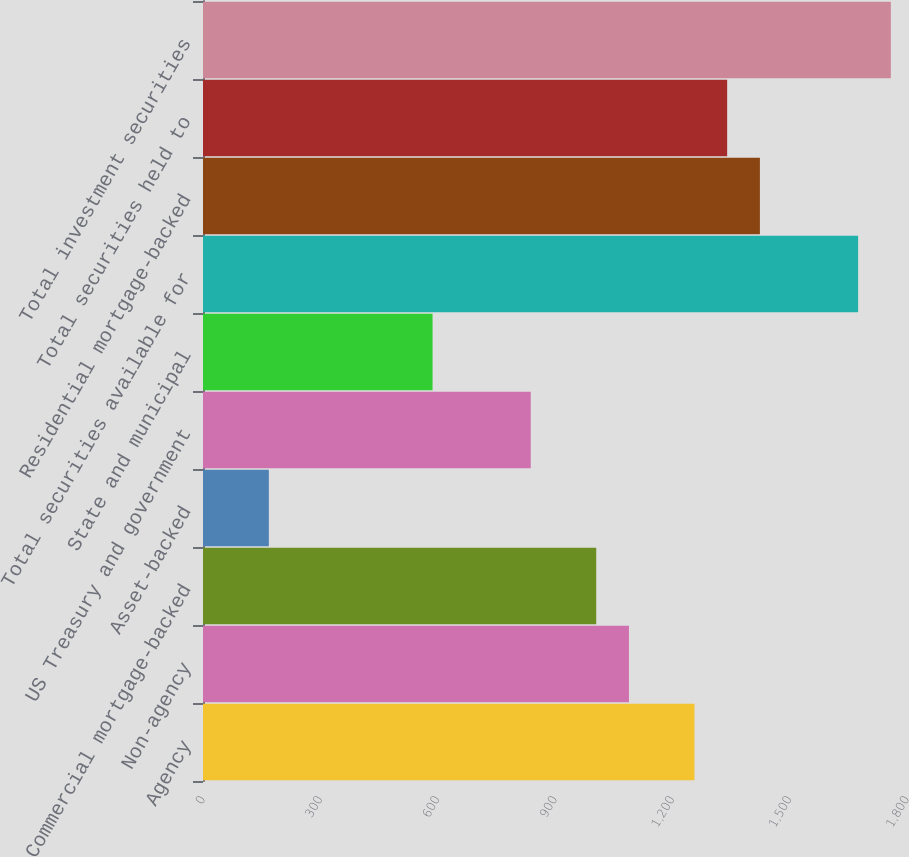Convert chart to OTSL. <chart><loc_0><loc_0><loc_500><loc_500><bar_chart><fcel>Agency<fcel>Non-agency<fcel>Commercial mortgage-backed<fcel>Asset-backed<fcel>US Treasury and government<fcel>State and municipal<fcel>Total securities available for<fcel>Residential mortgage-backed<fcel>Total securities held to<fcel>Total investment securities<nl><fcel>1256.5<fcel>1089.1<fcel>1005.4<fcel>168.4<fcel>838<fcel>586.9<fcel>1675<fcel>1423.9<fcel>1340.2<fcel>1758.7<nl></chart> 